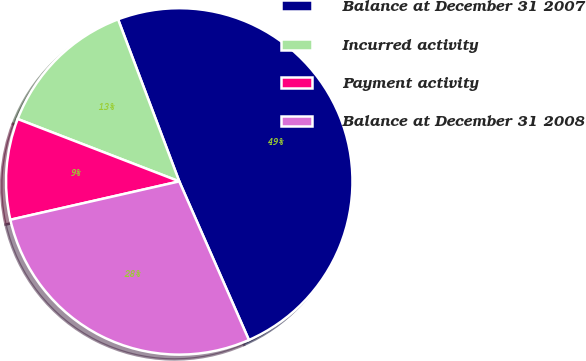Convert chart to OTSL. <chart><loc_0><loc_0><loc_500><loc_500><pie_chart><fcel>Balance at December 31 2007<fcel>Incurred activity<fcel>Payment activity<fcel>Balance at December 31 2008<nl><fcel>49.16%<fcel>13.39%<fcel>9.42%<fcel>28.03%<nl></chart> 